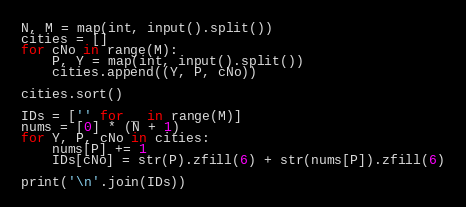Convert code to text. <code><loc_0><loc_0><loc_500><loc_500><_Python_>N, M = map(int, input().split())
cities = []
for cNo in range(M):
    P, Y = map(int, input().split())
    cities.append((Y, P, cNo))

cities.sort()

IDs = ['' for _ in range(M)]
nums = [0] * (N + 1)
for Y, P, cNo in cities:
    nums[P] += 1
    IDs[cNo] = str(P).zfill(6) + str(nums[P]).zfill(6)

print('\n'.join(IDs))
</code> 